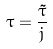<formula> <loc_0><loc_0><loc_500><loc_500>\tau = \frac { \tilde { \tau } } { j }</formula> 